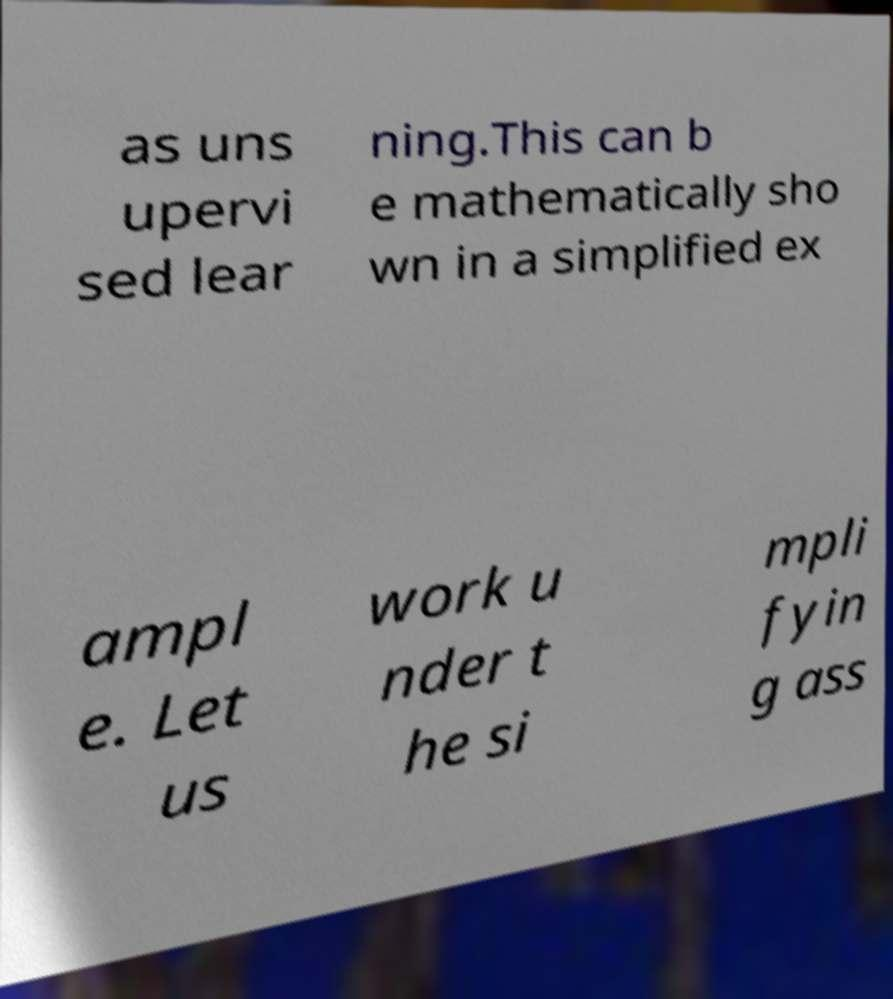Please identify and transcribe the text found in this image. as uns upervi sed lear ning.This can b e mathematically sho wn in a simplified ex ampl e. Let us work u nder t he si mpli fyin g ass 